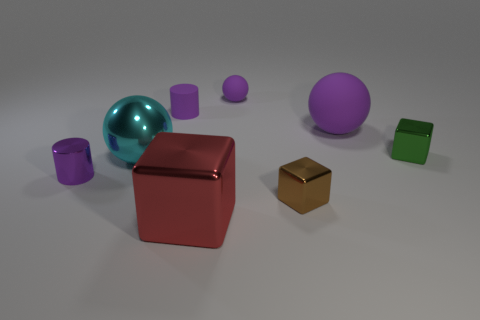Does the large rubber object have the same color as the sphere that is in front of the tiny green shiny object? no 